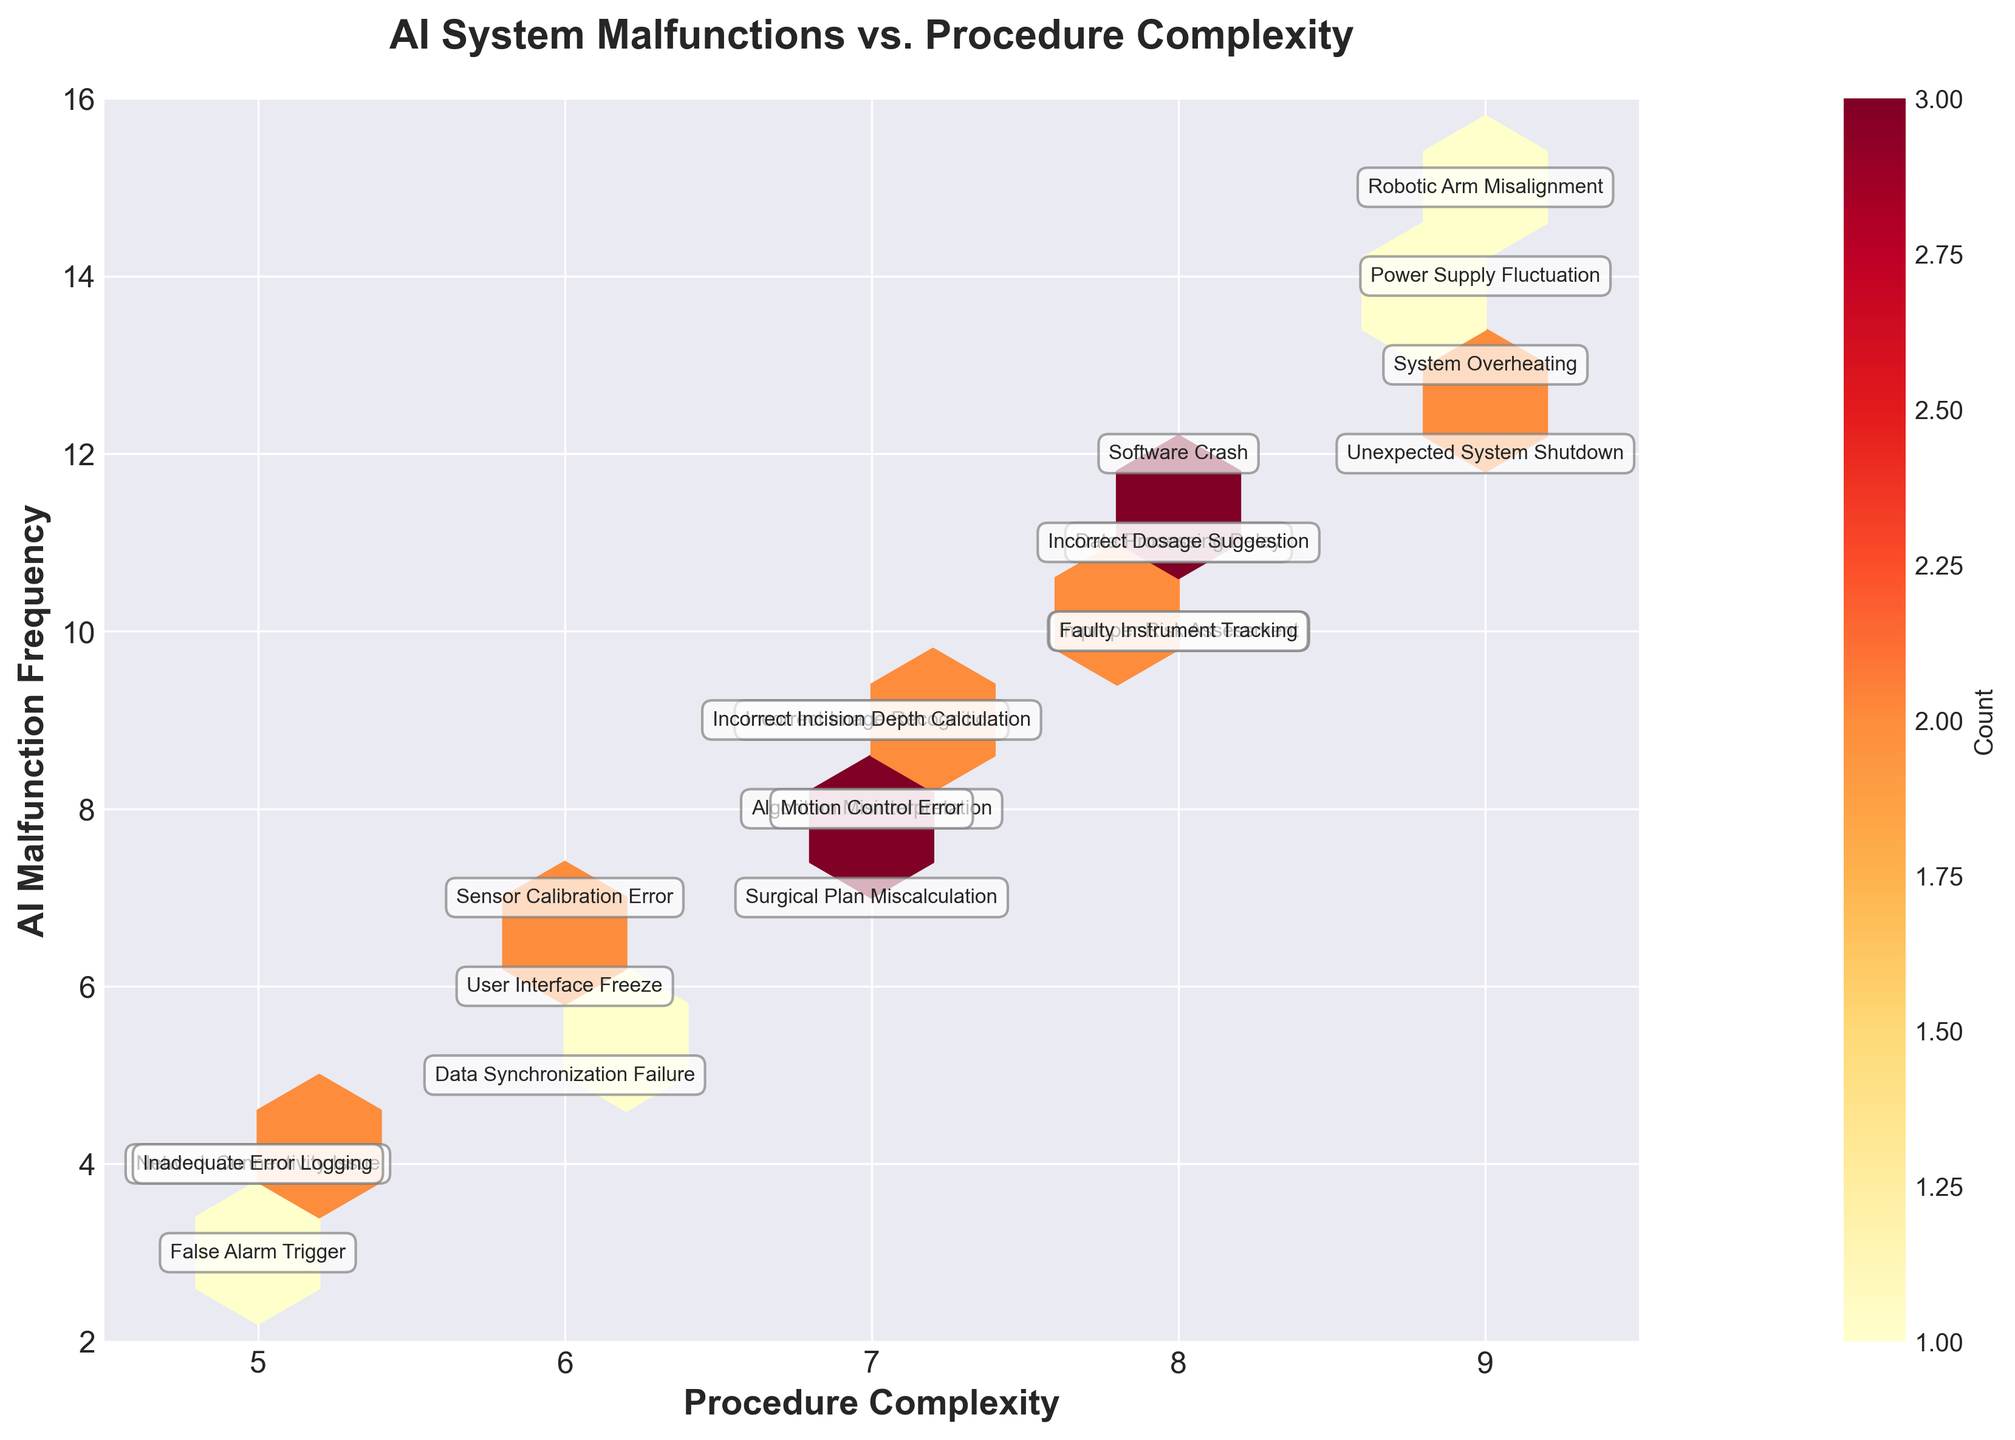What is the title of the plot? The title is usually given at the top of the plot. Here, it is "AI System Malfunctions vs. Procedure Complexity".
Answer: AI System Malfunctions vs. Procedure Complexity What are the labels of the x-axis and y-axis? The axis labels are typically positioned along the respective axes. For this figure, "Procedure Complexity" is along the x-axis, and "AI Malfunction Frequency" is along the y-axis.
Answer: Procedure Complexity and AI Malfunction Frequency How many distinct colors are used in the hexbin plot to represent the counts? A hexbin plot typically uses different shades of a single color to represent counts. In this plot, the color scale ranges from light to dark in 'YlOrRd' (yellow-orange-red) to show different densities.
Answer: Multiple shades from light yellow to dark red Which malfunction type has the highest AI malfunction frequency and what is its value? By finding the highest point on the y-axis and checking the label, "Robotic Arm Misalignment" corresponds to an AI malfunction frequency of 15.
Answer: Robotic Arm Misalignment, 15 For a procedure complexity of 7, what are the two highest AI malfunction frequencies, and what are their respective malfunction types? By looking at the vertical line at '7' on the x-axis and reading the labeled points, "Incorrect Image Recognition" and "Algorithm Misinterpretation” both have associated frequencies: 9 and 8 respectively.
Answer: Incorrect Image Recognition (9), Algorithm Misinterpretation (8) What is the average AI malfunction frequency for procedures with a complexity of 8? Locate all frequencies where the procedure complexity is 8 and average them. The values are 12, 11, 11, 10, and 10. Their average is (12 + 11 + 11 + 10 + 10) / 5 = 10.8
Answer: 10.8 Which procedure complexity points have the lowest AI malfunction frequency, and identify the malfunction type at that point? Check the lowest point on the y-axis, which intersects with the complexity. Here, the lowest is '3' with a complexity of '5', labeled as "False Alarm Trigger".
Answer: 5, False Alarm Trigger Do more complex procedures (8 or 9 complexity) generally have higher AI malfunction frequencies? Compare the frequencies at complexities 8 and 9 to those at lower complexities. Points at 8 and 9 have higher frequencies, indicating more frequent malfunctions.
Answer: Yes Is there a particular malfunction type that appears more than once? If so, what is it and its procedure complexity and frequency values? By inspecting the plot labels, "Incorrect Incision Depth Calculation" and "Algorithm Misinterpretation” appear more than once with various complexities and frequencies.
Answer: Incorrect Incision Depth Calculation (7, 9), Algorithm Misinterpretation (7, 8) What does the color bar to the right of the plot represent? The color bar signifies the density of data points in the hexbin plot, indicating how many data points fall into each hexagonal bin, with darker colors representing higher densities.
Answer: Count 